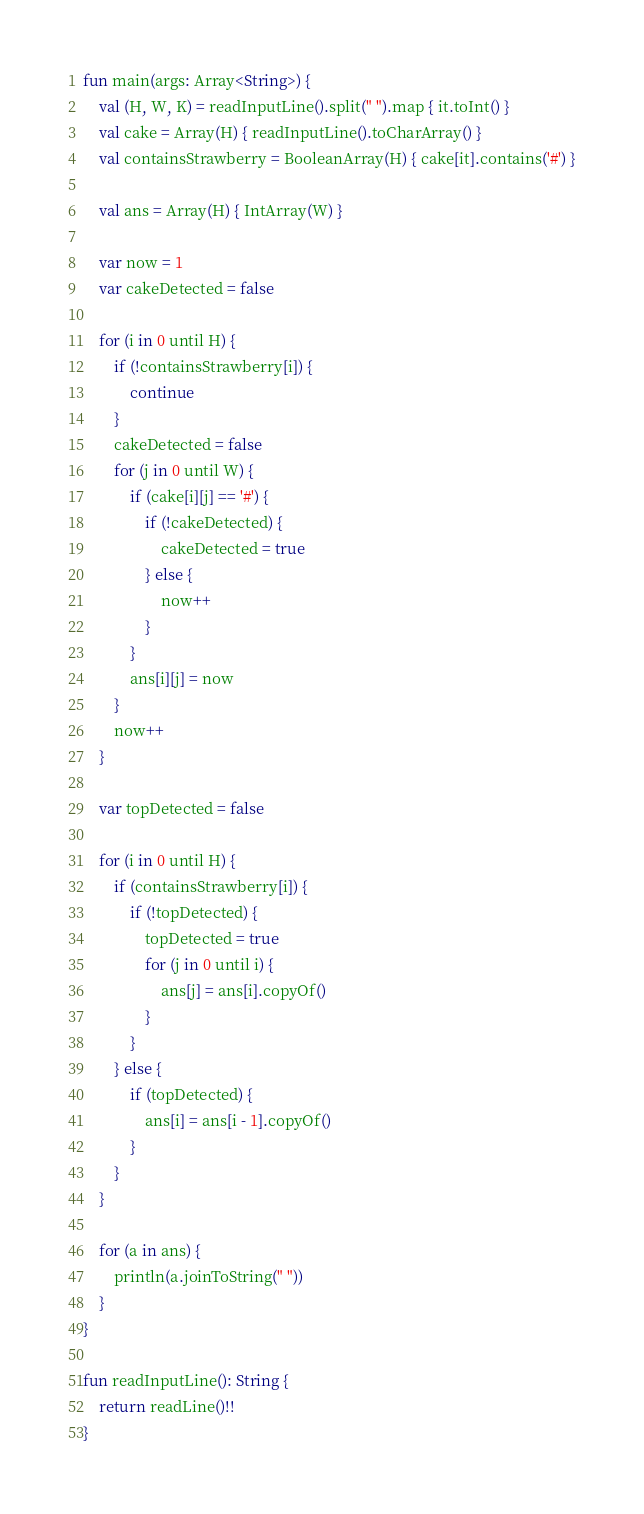<code> <loc_0><loc_0><loc_500><loc_500><_Kotlin_>fun main(args: Array<String>) {
    val (H, W, K) = readInputLine().split(" ").map { it.toInt() }
    val cake = Array(H) { readInputLine().toCharArray() }
    val containsStrawberry = BooleanArray(H) { cake[it].contains('#') }
    
    val ans = Array(H) { IntArray(W) }

    var now = 1
    var cakeDetected = false

    for (i in 0 until H) {
        if (!containsStrawberry[i]) {
            continue
        }
        cakeDetected = false
        for (j in 0 until W) {
            if (cake[i][j] == '#') {
                if (!cakeDetected) {
                    cakeDetected = true
                } else {
                    now++
                }
            }
            ans[i][j] = now
        }
        now++
    }
    
    var topDetected = false
    
    for (i in 0 until H) {
        if (containsStrawberry[i]) {
            if (!topDetected) {
                topDetected = true
                for (j in 0 until i) {
                    ans[j] = ans[i].copyOf()
                }
            }
        } else {
            if (topDetected) {
                ans[i] = ans[i - 1].copyOf()
            }
        }
    }

    for (a in ans) {
        println(a.joinToString(" "))
    }
}

fun readInputLine(): String {
    return readLine()!!
}
</code> 